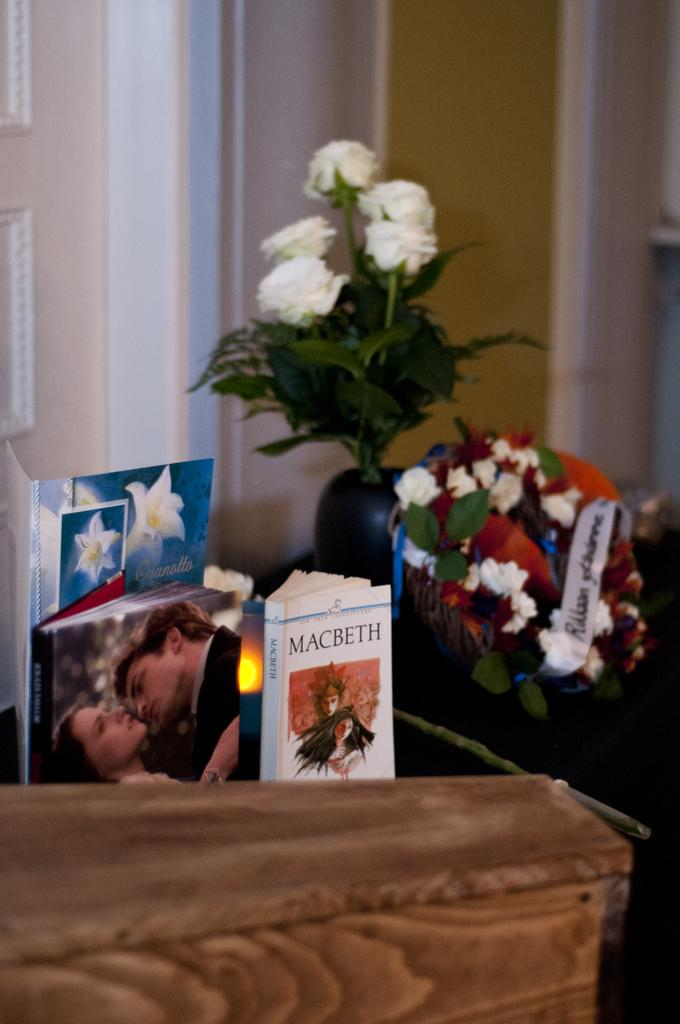What objects can be seen on the left side of the image? There are books on the left side of the image. What type of plants are on the right side of the image? There are plants with flowers on the right side of the image. What can be seen in the background of the image? There is a wall in the background of the image. Where is the monkey playing in the image? There is no monkey present in the image. Can you see any cobwebs in the image? There is no mention of cobwebs in the provided facts, so we cannot determine if they are present in the image. 